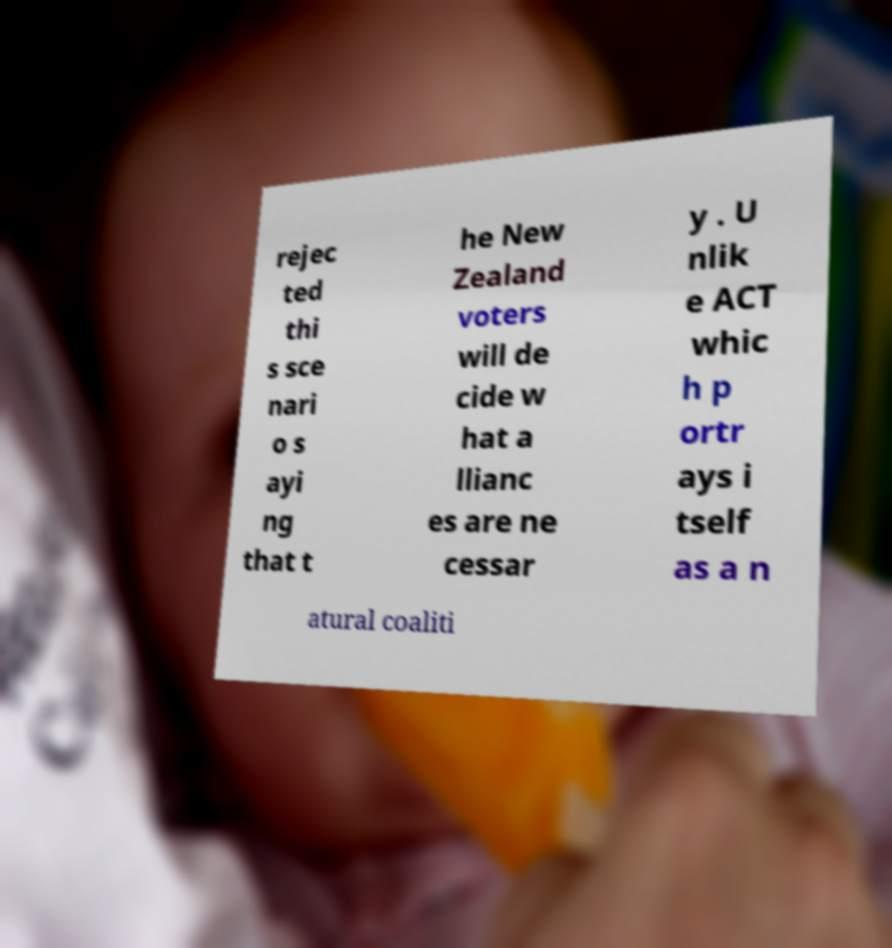There's text embedded in this image that I need extracted. Can you transcribe it verbatim? rejec ted thi s sce nari o s ayi ng that t he New Zealand voters will de cide w hat a llianc es are ne cessar y . U nlik e ACT whic h p ortr ays i tself as a n atural coaliti 